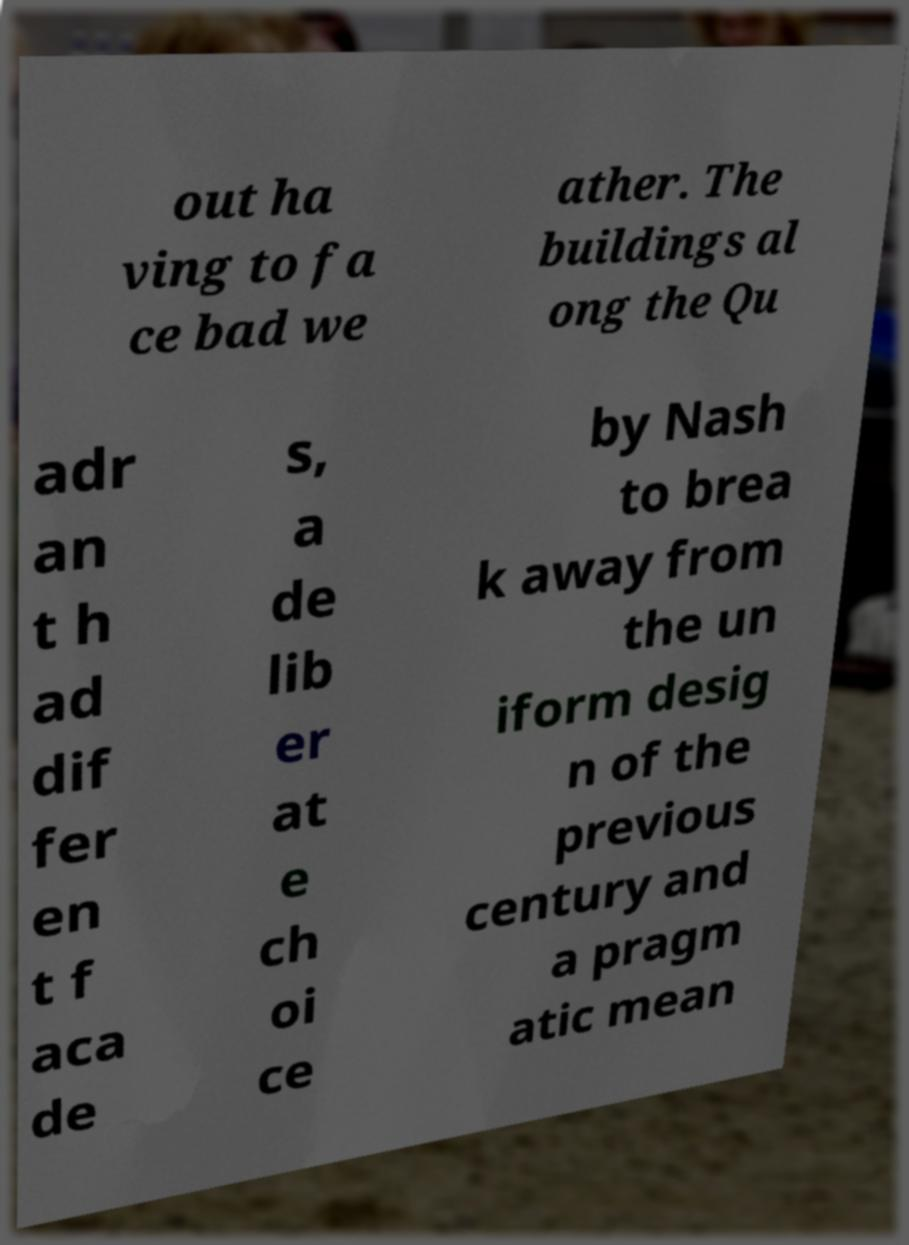Please read and relay the text visible in this image. What does it say? out ha ving to fa ce bad we ather. The buildings al ong the Qu adr an t h ad dif fer en t f aca de s, a de lib er at e ch oi ce by Nash to brea k away from the un iform desig n of the previous century and a pragm atic mean 